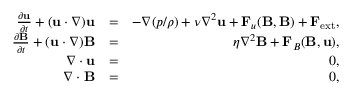Convert formula to latex. <formula><loc_0><loc_0><loc_500><loc_500>\begin{array} { r l r } { \frac { \partial { u } } { \partial t } + ( { u } \cdot \nabla ) { u } } & { = } & { - \nabla ( { p } / { \rho } ) + \nu \nabla ^ { 2 } { u } + { F } _ { u } ( { B , B } ) + { F } _ { e x t } , } \\ { \frac { \partial { B } } { \partial t } + ( { u } \cdot \nabla ) { B } } & { = } & { \eta \nabla ^ { 2 } { B } + { F } _ { B } ( { B , u } ) , } \\ { \nabla \cdot { u } } & { = } & { 0 , } \\ { \nabla \cdot { B } } & { = } & { 0 , } \end{array}</formula> 